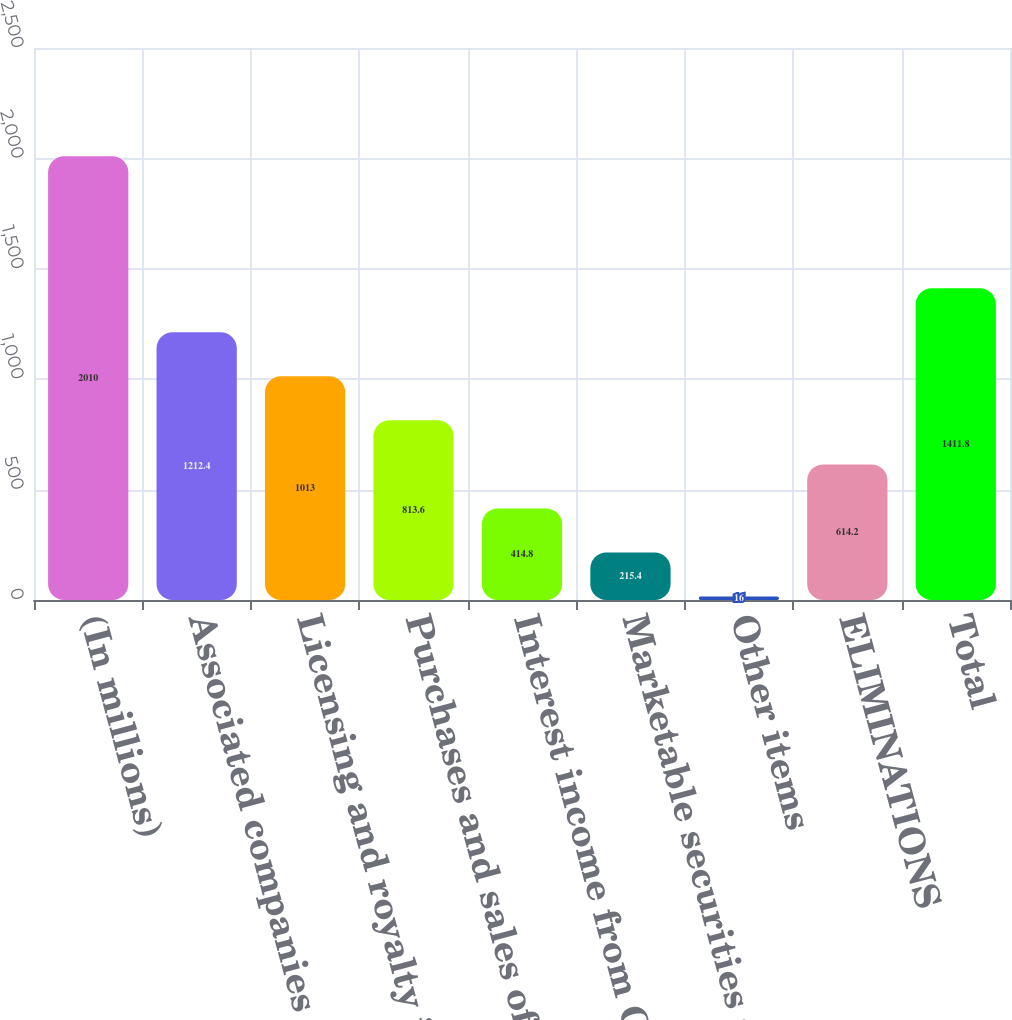Convert chart to OTSL. <chart><loc_0><loc_0><loc_500><loc_500><bar_chart><fcel>(In millions)<fcel>Associated companies ^(a)<fcel>Licensing and royalty income<fcel>Purchases and sales of<fcel>Interest income from GECS<fcel>Marketable securities and bank<fcel>Other items<fcel>ELIMINATIONS<fcel>Total<nl><fcel>2010<fcel>1212.4<fcel>1013<fcel>813.6<fcel>414.8<fcel>215.4<fcel>16<fcel>614.2<fcel>1411.8<nl></chart> 